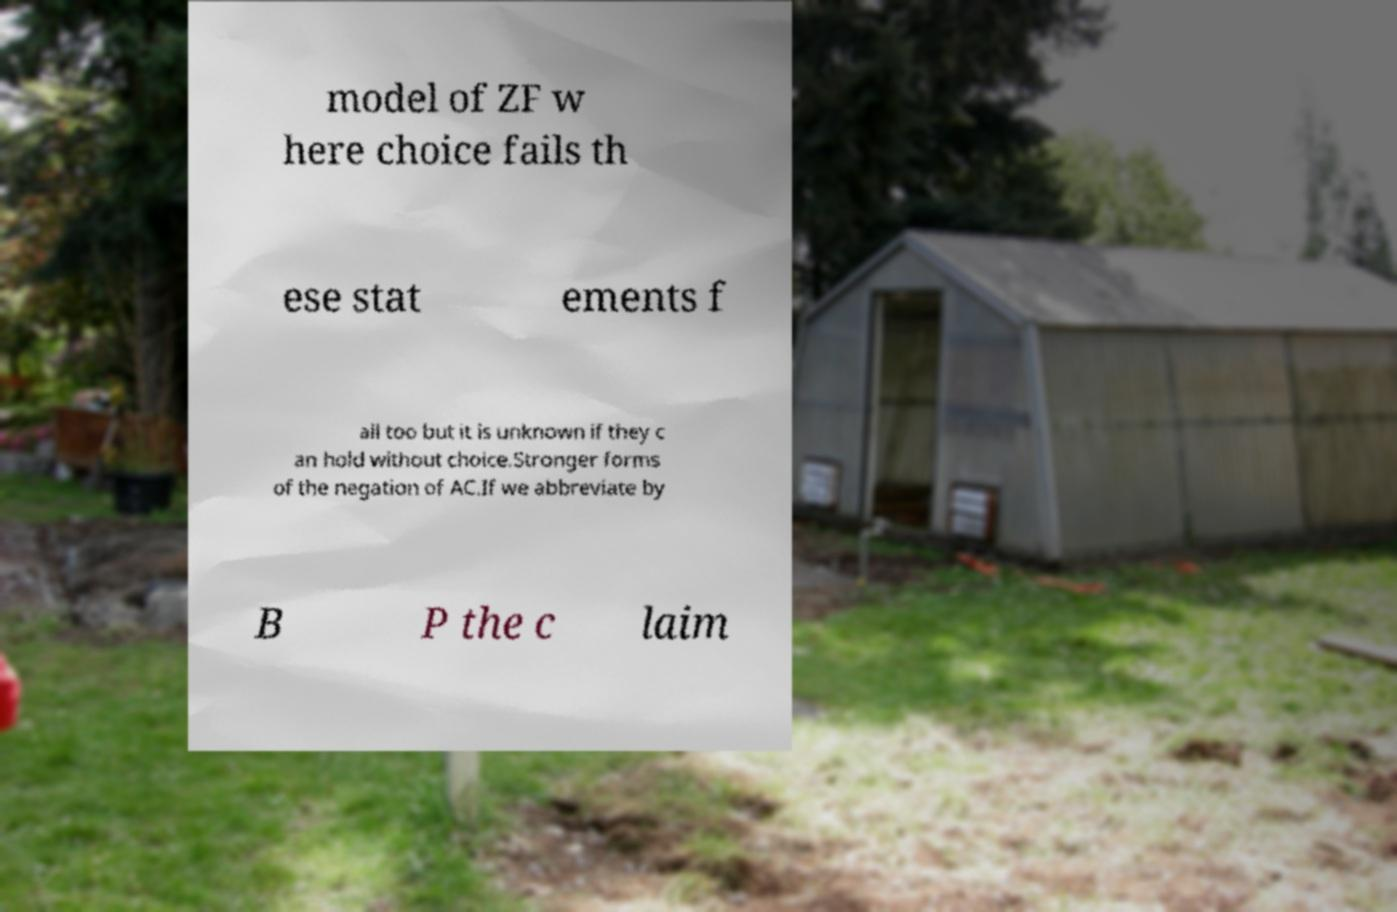Please identify and transcribe the text found in this image. model of ZF w here choice fails th ese stat ements f ail too but it is unknown if they c an hold without choice.Stronger forms of the negation of AC.If we abbreviate by B P the c laim 